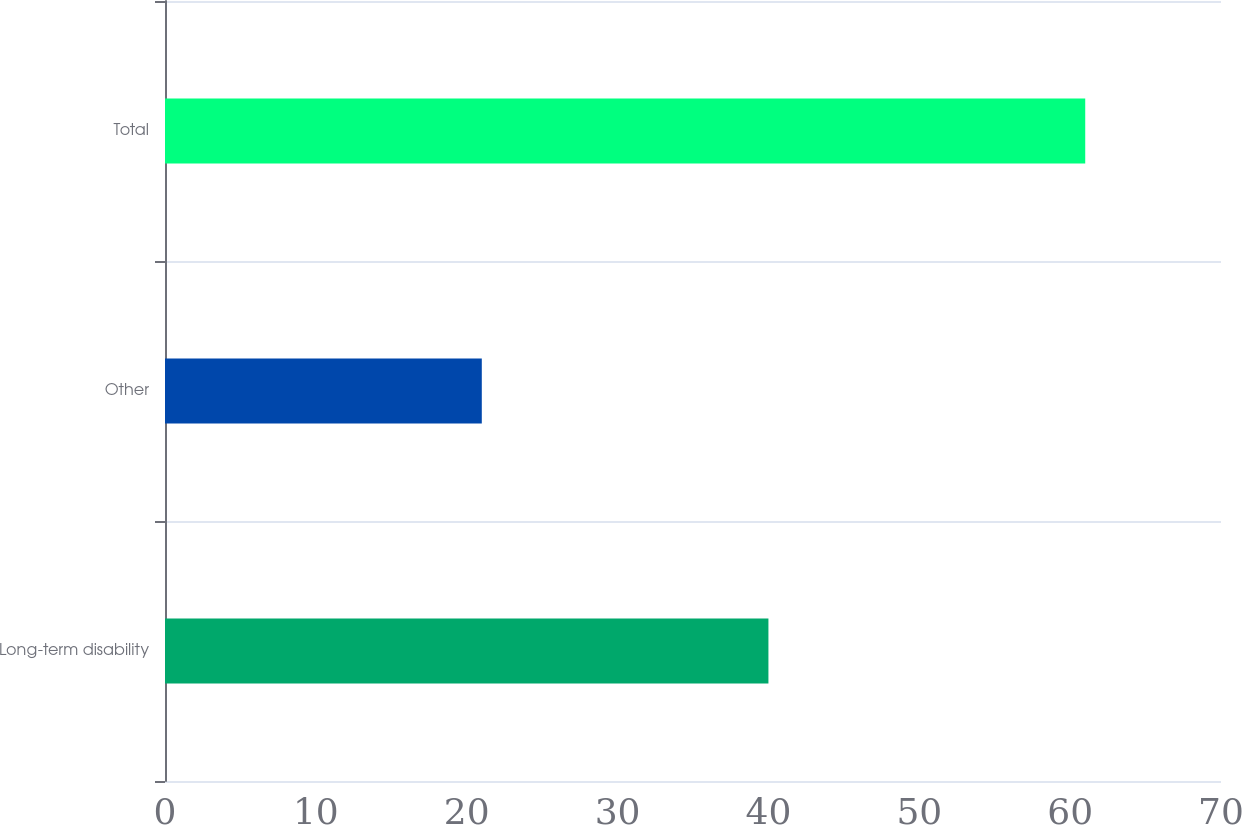Convert chart to OTSL. <chart><loc_0><loc_0><loc_500><loc_500><bar_chart><fcel>Long-term disability<fcel>Other<fcel>Total<nl><fcel>40<fcel>21<fcel>61<nl></chart> 